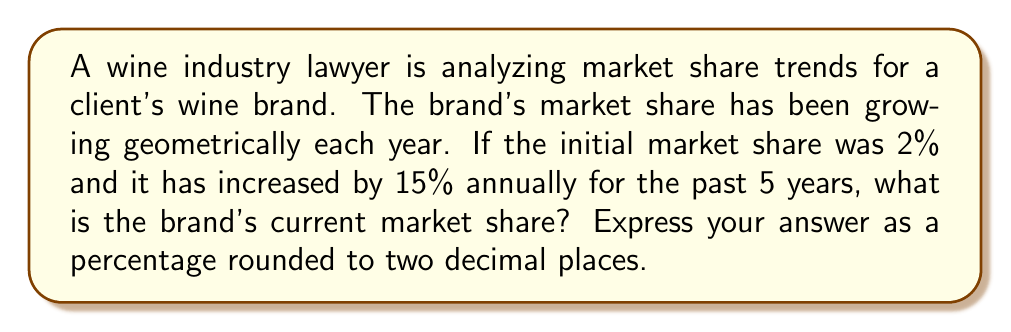Teach me how to tackle this problem. Let's approach this step-by-step using the concept of geometric sequences:

1) In a geometric sequence, each term is a constant multiple of the previous term. In this case, the constant multiple is 1.15 (115% of the previous year's share).

2) The initial term (a₁) is 2% or 0.02 in decimal form.

3) The common ratio (r) is 1.15.

4) We need to find the 6th term (a₆) as we're looking at the current share after 5 years of growth.

5) The formula for the nth term of a geometric sequence is:

   $$a_n = a_1 \cdot r^{n-1}$$

6) Plugging in our values:

   $$a_6 = 0.02 \cdot (1.15)^{6-1} = 0.02 \cdot (1.15)^5$$

7) Let's calculate this:

   $$0.02 \cdot (1.15)^5 = 0.02 \cdot 2.0113689 = 0.04022737$$

8) Converting to a percentage and rounding to two decimal places:

   $$0.04022737 \cdot 100 \approx 4.02\%$$

Therefore, the brand's current market share is approximately 4.02%.
Answer: 4.02% 